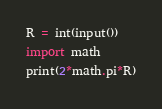<code> <loc_0><loc_0><loc_500><loc_500><_Python_>R = int(input())
import math
print(2*math.pi*R)</code> 